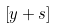<formula> <loc_0><loc_0><loc_500><loc_500>\left [ { y + s } \right ]</formula> 